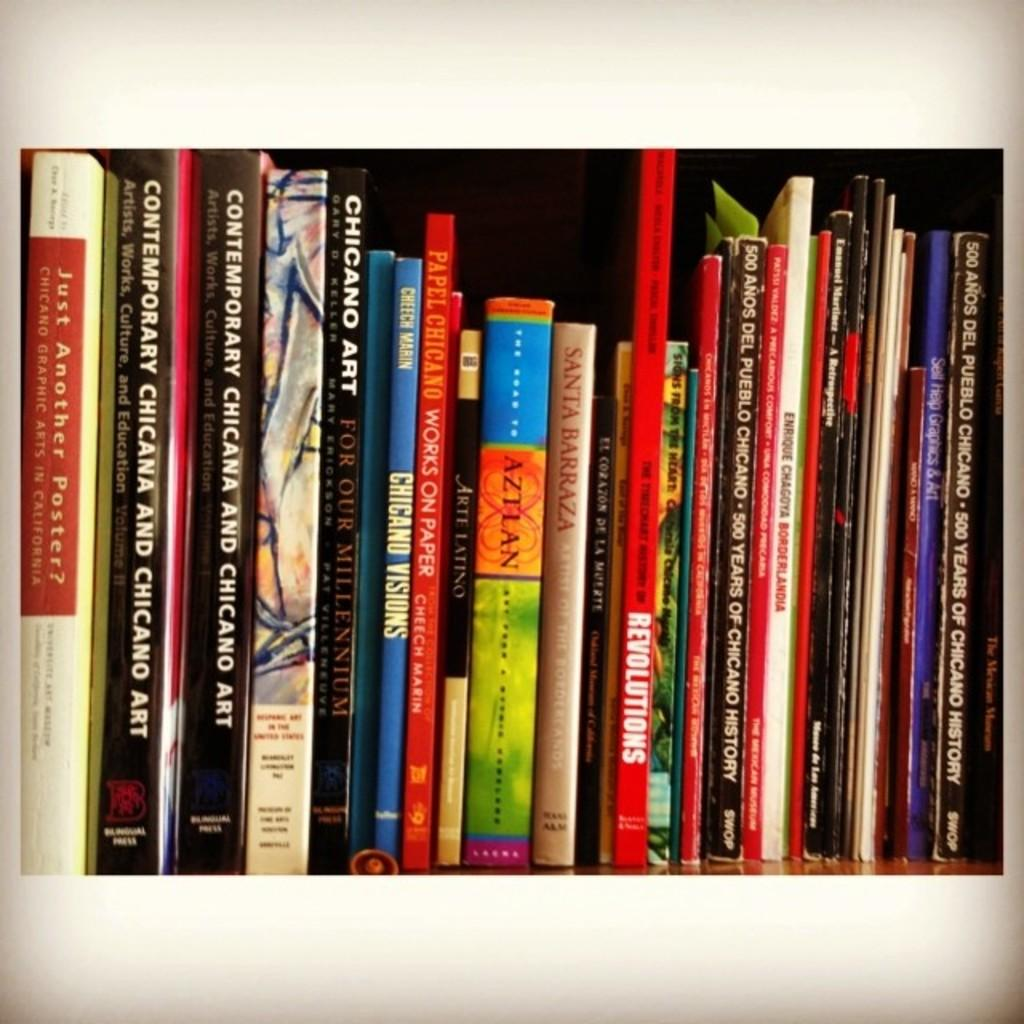<image>
Summarize the visual content of the image. The skinny red book has the word Revolutions written in white on it 